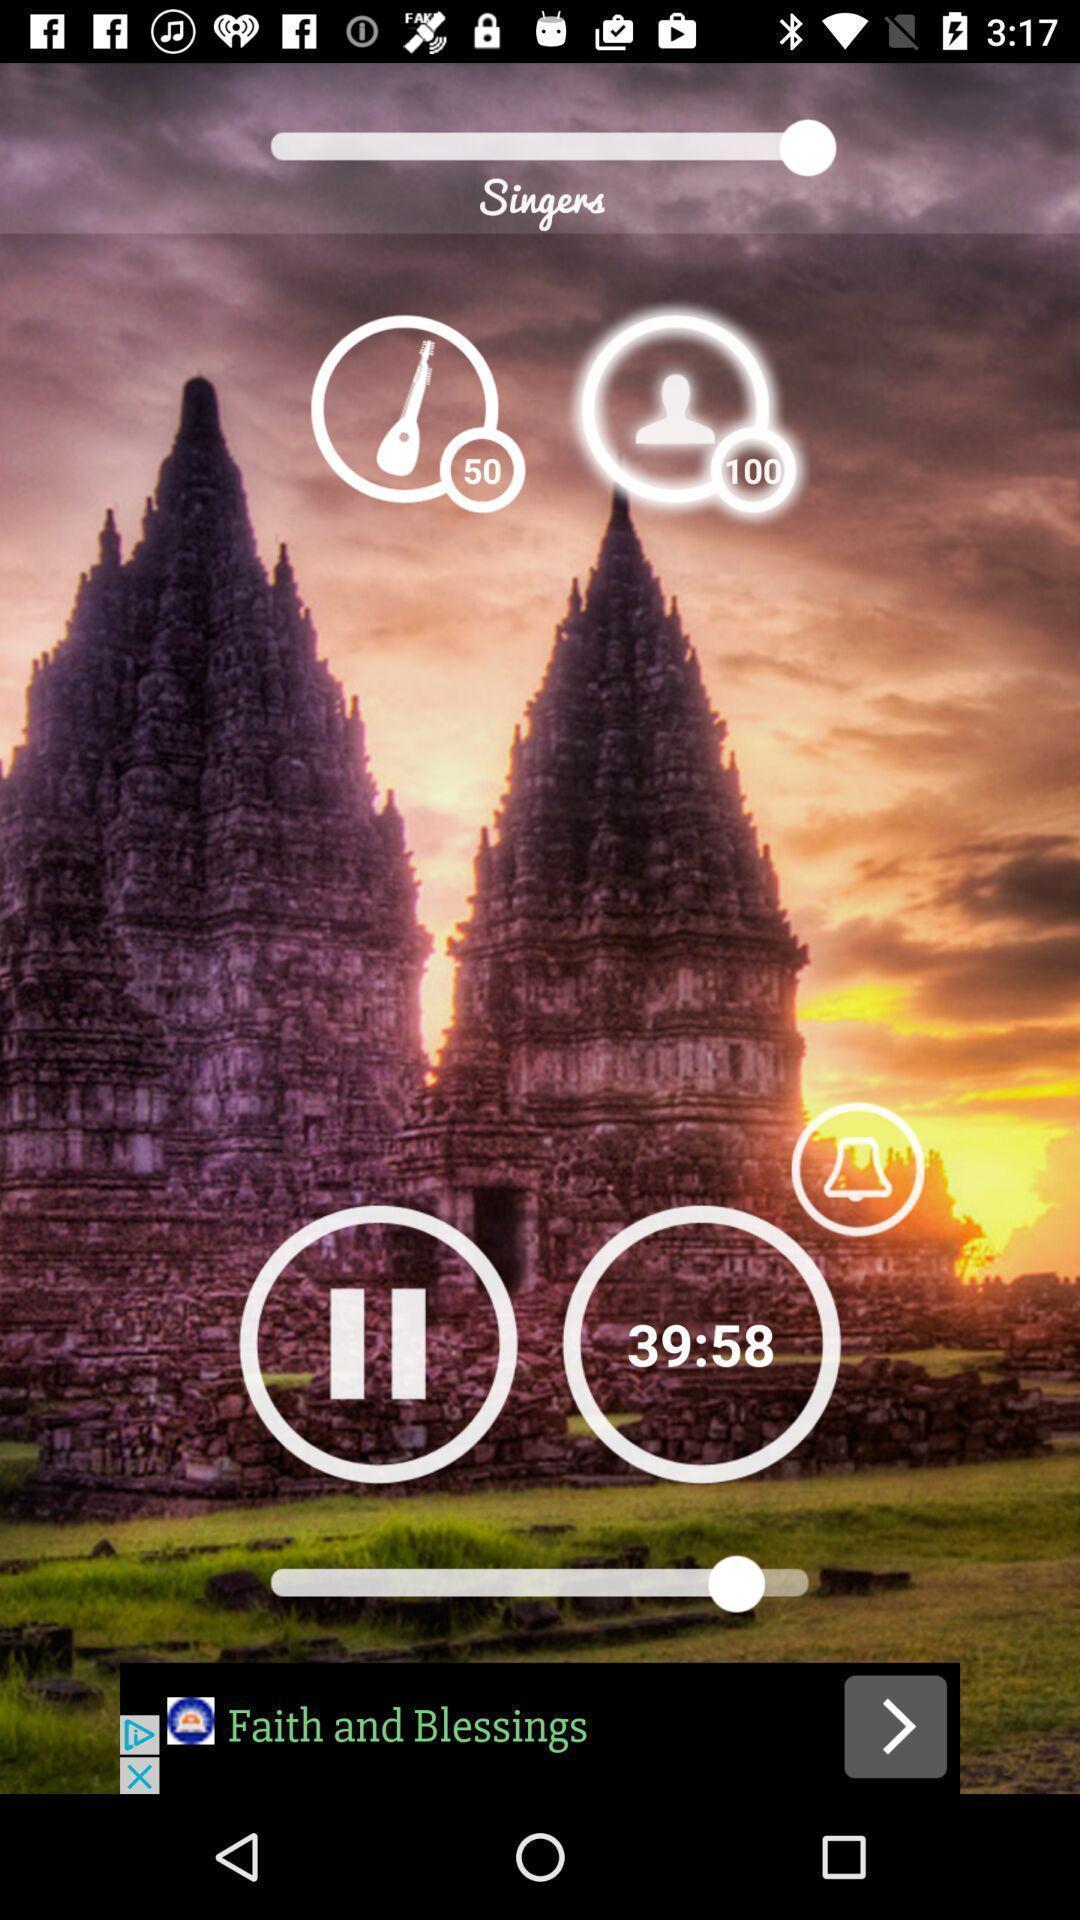Summarize the main components in this picture. Screen shows player option in a music app. 